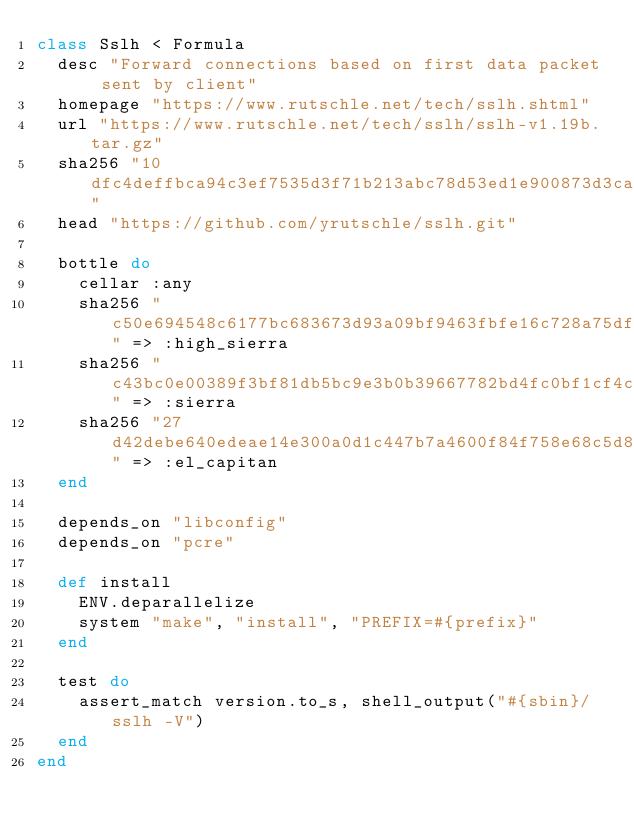<code> <loc_0><loc_0><loc_500><loc_500><_Ruby_>class Sslh < Formula
  desc "Forward connections based on first data packet sent by client"
  homepage "https://www.rutschle.net/tech/sslh.shtml"
  url "https://www.rutschle.net/tech/sslh/sslh-v1.19b.tar.gz"
  sha256 "10dfc4deffbca94c3ef7535d3f71b213abc78d53ed1e900873d3ca1cc943659c"
  head "https://github.com/yrutschle/sslh.git"

  bottle do
    cellar :any
    sha256 "c50e694548c6177bc683673d93a09bf9463fbfe16c728a75df1b7619e9691a64" => :high_sierra
    sha256 "c43bc0e00389f3bf81db5bc9e3b0b39667782bd4fc0bf1cf4c5e4abc7e1a70e8" => :sierra
    sha256 "27d42debe640edeae14e300a0d1c447b7a4600f84f758e68c5d8c8246cade574" => :el_capitan
  end

  depends_on "libconfig"
  depends_on "pcre"

  def install
    ENV.deparallelize
    system "make", "install", "PREFIX=#{prefix}"
  end

  test do
    assert_match version.to_s, shell_output("#{sbin}/sslh -V")
  end
end
</code> 